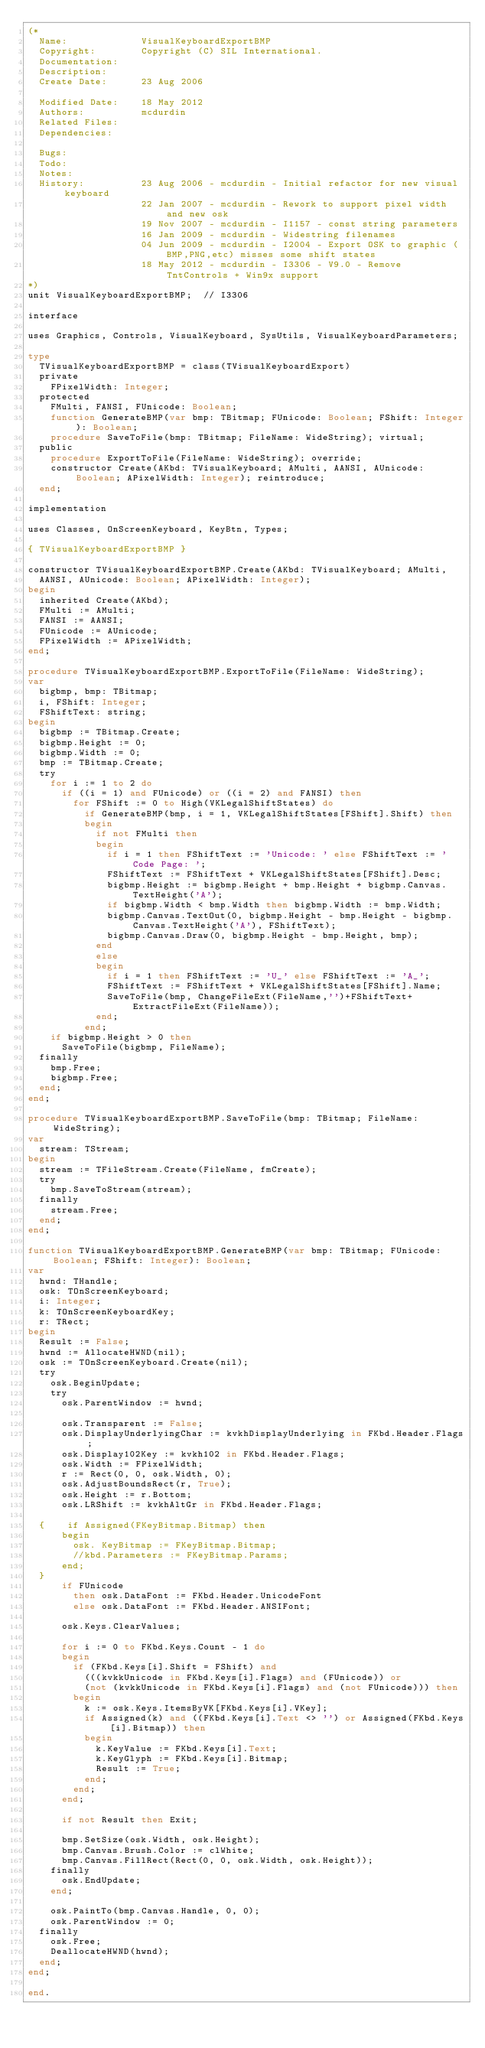<code> <loc_0><loc_0><loc_500><loc_500><_Pascal_>(*
  Name:             VisualKeyboardExportBMP
  Copyright:        Copyright (C) SIL International.
  Documentation:    
  Description:      
  Create Date:      23 Aug 2006

  Modified Date:    18 May 2012
  Authors:          mcdurdin
  Related Files:    
  Dependencies:     

  Bugs:             
  Todo:             
  Notes:            
  History:          23 Aug 2006 - mcdurdin - Initial refactor for new visual keyboard
                    22 Jan 2007 - mcdurdin - Rework to support pixel width and new osk
                    19 Nov 2007 - mcdurdin - I1157 - const string parameters
                    16 Jan 2009 - mcdurdin - Widestring filenames
                    04 Jun 2009 - mcdurdin - I2004 - Export OSK to graphic (BMP,PNG,etc) misses some shift states
                    18 May 2012 - mcdurdin - I3306 - V9.0 - Remove TntControls + Win9x support
*)
unit VisualKeyboardExportBMP;  // I3306

interface

uses Graphics, Controls, VisualKeyboard, SysUtils, VisualKeyboardParameters;

type
  TVisualKeyboardExportBMP = class(TVisualKeyboardExport)
  private
    FPixelWidth: Integer;
  protected
    FMulti, FANSI, FUnicode: Boolean;
    function GenerateBMP(var bmp: TBitmap; FUnicode: Boolean; FShift: Integer): Boolean;
    procedure SaveToFile(bmp: TBitmap; FileName: WideString); virtual;
  public
    procedure ExportToFile(FileName: WideString); override;
    constructor Create(AKbd: TVisualKeyboard; AMulti, AANSI, AUnicode: Boolean; APixelWidth: Integer); reintroduce;
  end;

implementation

uses Classes, OnScreenKeyboard, KeyBtn, Types;

{ TVisualKeyboardExportBMP }

constructor TVisualKeyboardExportBMP.Create(AKbd: TVisualKeyboard; AMulti,
  AANSI, AUnicode: Boolean; APixelWidth: Integer);
begin
  inherited Create(AKbd);
  FMulti := AMulti;
  FANSI := AANSI;
  FUnicode := AUnicode;
  FPixelWidth := APixelWidth;
end;

procedure TVisualKeyboardExportBMP.ExportToFile(FileName: WideString);
var
  bigbmp, bmp: TBitmap;
  i, FShift: Integer;
  FShiftText: string;
begin
  bigbmp := TBitmap.Create;
  bigbmp.Height := 0;
  bigbmp.Width := 0;
  bmp := TBitmap.Create;
  try
    for i := 1 to 2 do
      if ((i = 1) and FUnicode) or ((i = 2) and FANSI) then
        for FShift := 0 to High(VKLegalShiftStates) do
          if GenerateBMP(bmp, i = 1, VKLegalShiftStates[FShift].Shift) then
          begin
            if not FMulti then
            begin
              if i = 1 then FShiftText := 'Unicode: ' else FShiftText := 'Code Page: ';
              FShiftText := FShiftText + VKLegalShiftStates[FShift].Desc;
              bigbmp.Height := bigbmp.Height + bmp.Height + bigbmp.Canvas.TextHeight('A');
              if bigbmp.Width < bmp.Width then bigbmp.Width := bmp.Width;
              bigbmp.Canvas.TextOut(0, bigbmp.Height - bmp.Height - bigbmp.Canvas.TextHeight('A'), FShiftText);
              bigbmp.Canvas.Draw(0, bigbmp.Height - bmp.Height, bmp);
            end
            else
            begin
              if i = 1 then FShiftText := 'U_' else FShiftText := 'A_';
              FShiftText := FShiftText + VKLegalShiftStates[FShift].Name;
              SaveToFile(bmp, ChangeFileExt(FileName,'')+FShiftText+ExtractFileExt(FileName));
            end;
          end;
    if bigbmp.Height > 0 then
      SaveToFile(bigbmp, FileName);
  finally
    bmp.Free;
    bigbmp.Free;
  end;
end;

procedure TVisualKeyboardExportBMP.SaveToFile(bmp: TBitmap; FileName: WideString);
var
  stream: TStream;
begin
  stream := TFileStream.Create(FileName, fmCreate);
  try
    bmp.SaveToStream(stream);
  finally
    stream.Free;
  end;
end;

function TVisualKeyboardExportBMP.GenerateBMP(var bmp: TBitmap; FUnicode: Boolean; FShift: Integer): Boolean;
var
  hwnd: THandle;
  osk: TOnScreenKeyboard;
  i: Integer;
  k: TOnScreenKeyboardKey;
  r: TRect;
begin
  Result := False;
  hwnd := AllocateHWND(nil);
  osk := TOnScreenKeyboard.Create(nil);
  try
    osk.BeginUpdate;
    try
      osk.ParentWindow := hwnd;

      osk.Transparent := False;
      osk.DisplayUnderlyingChar := kvkhDisplayUnderlying in FKbd.Header.Flags;
      osk.Display102Key := kvkh102 in FKbd.Header.Flags;
      osk.Width := FPixelWidth;
      r := Rect(0, 0, osk.Width, 0);
      osk.AdjustBoundsRect(r, True);
      osk.Height := r.Bottom;
      osk.LRShift := kvkhAltGr in FKbd.Header.Flags;

  {    if Assigned(FKeyBitmap.Bitmap) then
      begin
        osk. KeyBitmap := FKeyBitmap.Bitmap;
        //kbd.Parameters := FKeyBitmap.Params;
      end;
  }
      if FUnicode
        then osk.DataFont := FKbd.Header.UnicodeFont
        else osk.DataFont := FKbd.Header.ANSIFont;

      osk.Keys.ClearValues;

      for i := 0 to FKbd.Keys.Count - 1 do
      begin
        if (FKbd.Keys[i].Shift = FShift) and
          (((kvkkUnicode in FKbd.Keys[i].Flags) and (FUnicode)) or
          (not (kvkkUnicode in FKbd.Keys[i].Flags) and (not FUnicode))) then
        begin
          k := osk.Keys.ItemsByVK[FKbd.Keys[i].VKey];
          if Assigned(k) and ((FKbd.Keys[i].Text <> '') or Assigned(FKbd.Keys[i].Bitmap)) then
          begin
            k.KeyValue := FKbd.Keys[i].Text;
            k.KeyGlyph := FKbd.Keys[i].Bitmap;
            Result := True;
          end;
        end;
      end;

      if not Result then Exit;

      bmp.SetSize(osk.Width, osk.Height);
      bmp.Canvas.Brush.Color := clWhite;
      bmp.Canvas.FillRect(Rect(0, 0, osk.Width, osk.Height));
    finally
      osk.EndUpdate;
    end;

    osk.PaintTo(bmp.Canvas.Handle, 0, 0);
    osk.ParentWindow := 0;
  finally
    osk.Free;
    DeallocateHWND(hwnd);
  end;
end;

end.
</code> 